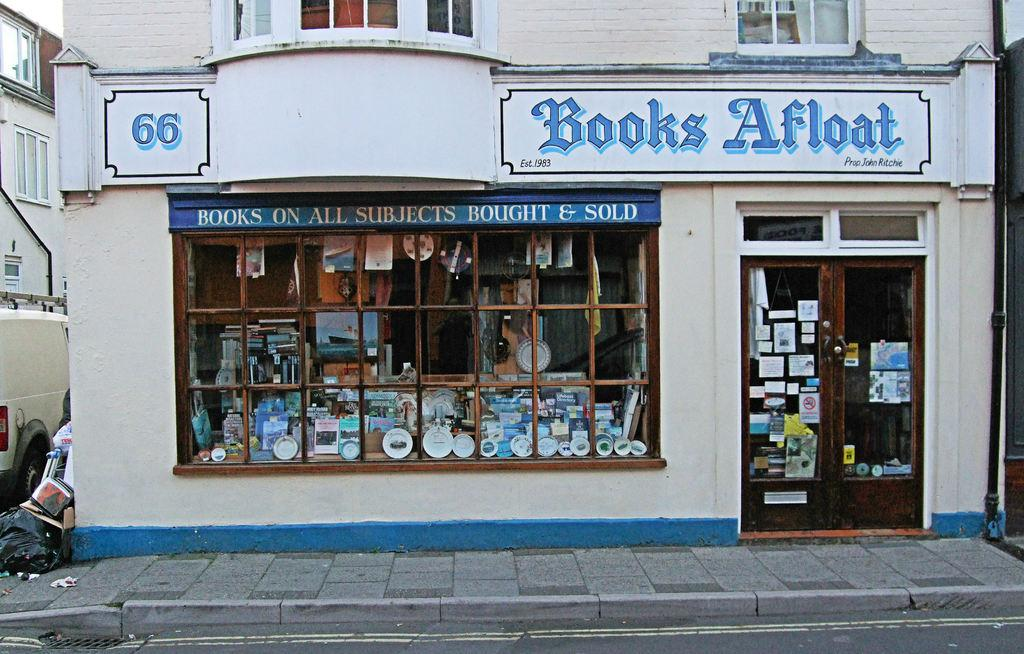<image>
Describe the image concisely. Books Afloat store by Prop John Ritchie, Store number 66, Books on all subjects bought & sold. 